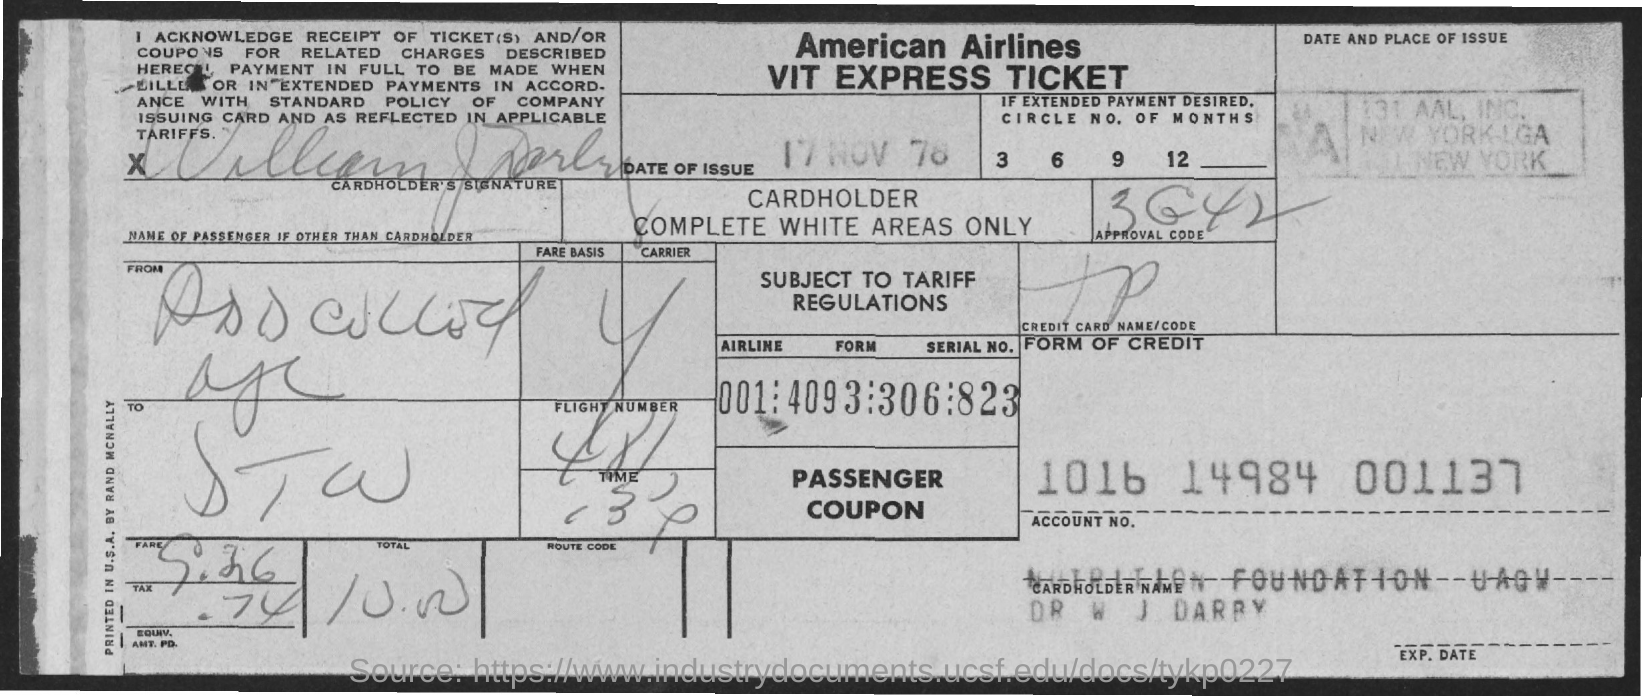Specify some key components in this picture. The date of issue is 17 November 1978. American Airlines is mentioned. The account number is 1016 14984 001137... 